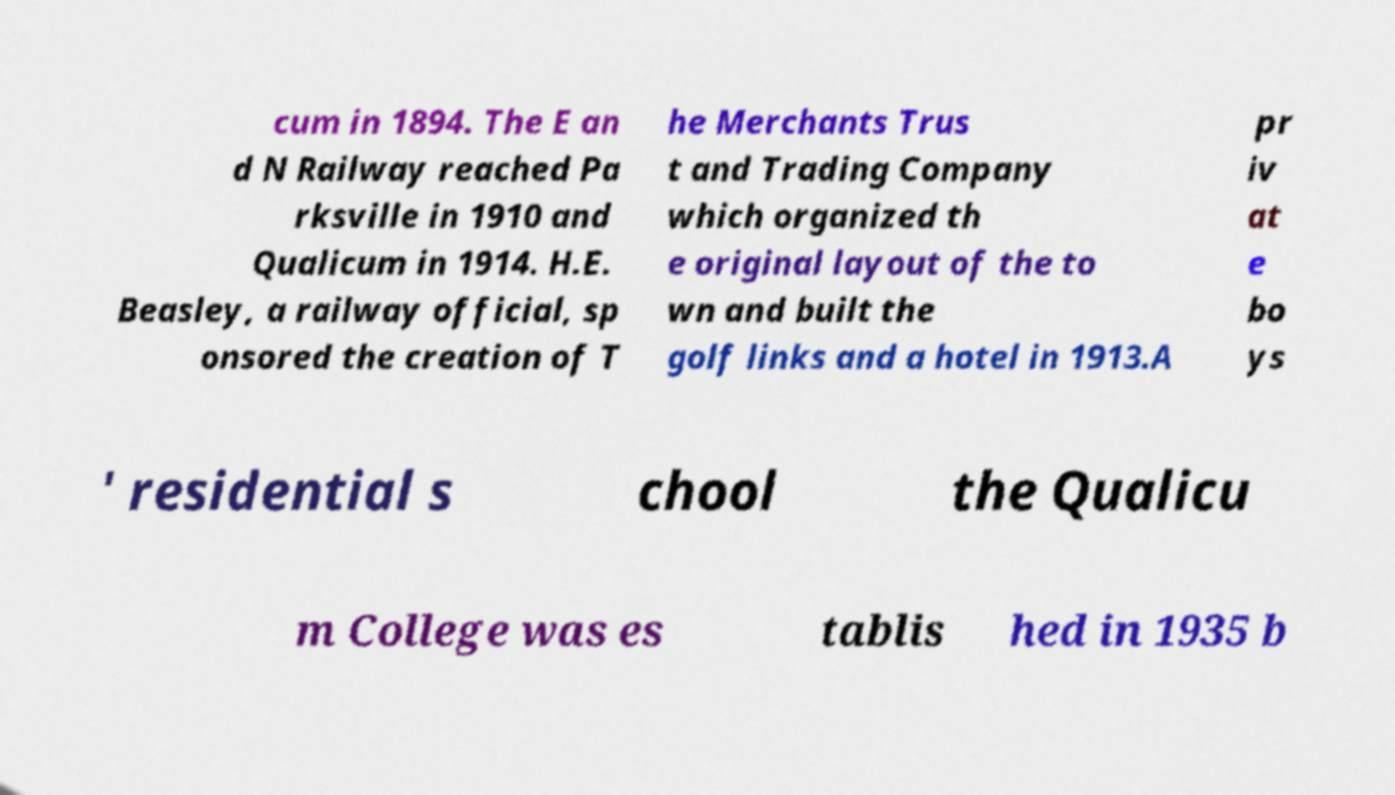Please read and relay the text visible in this image. What does it say? cum in 1894. The E an d N Railway reached Pa rksville in 1910 and Qualicum in 1914. H.E. Beasley, a railway official, sp onsored the creation of T he Merchants Trus t and Trading Company which organized th e original layout of the to wn and built the golf links and a hotel in 1913.A pr iv at e bo ys ' residential s chool the Qualicu m College was es tablis hed in 1935 b 